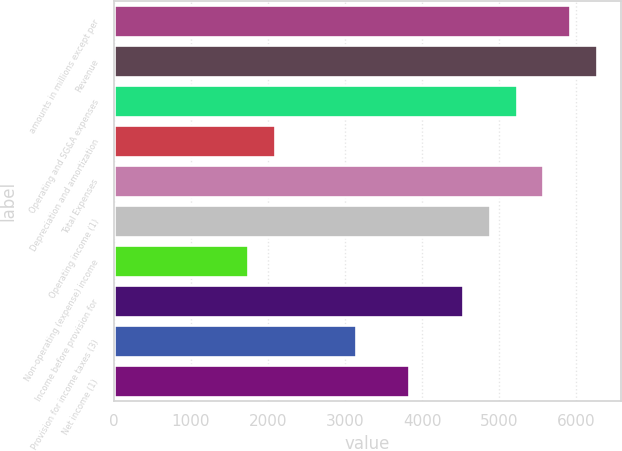Convert chart. <chart><loc_0><loc_0><loc_500><loc_500><bar_chart><fcel>amounts in millions except per<fcel>Revenue<fcel>Operating and SG&A expenses<fcel>Depreciation and amortization<fcel>Total Expenses<fcel>Operating income (1)<fcel>Non-operating (expense) income<fcel>Income before provision for<fcel>Provision for income taxes (3)<fcel>Net income (1)<nl><fcel>5922.66<fcel>6270.97<fcel>5226.04<fcel>2091.25<fcel>5574.35<fcel>4877.73<fcel>1742.94<fcel>4529.42<fcel>3136.18<fcel>3832.8<nl></chart> 